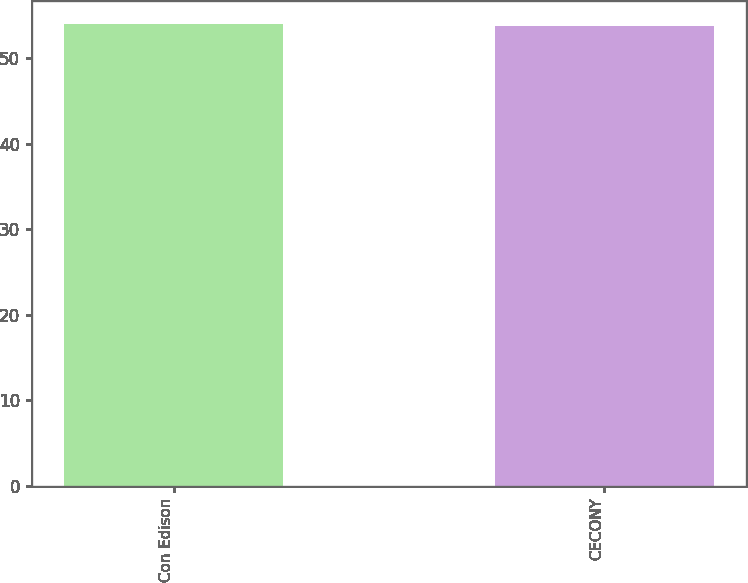Convert chart to OTSL. <chart><loc_0><loc_0><loc_500><loc_500><bar_chart><fcel>Con Edison<fcel>CECONY<nl><fcel>54<fcel>53.8<nl></chart> 